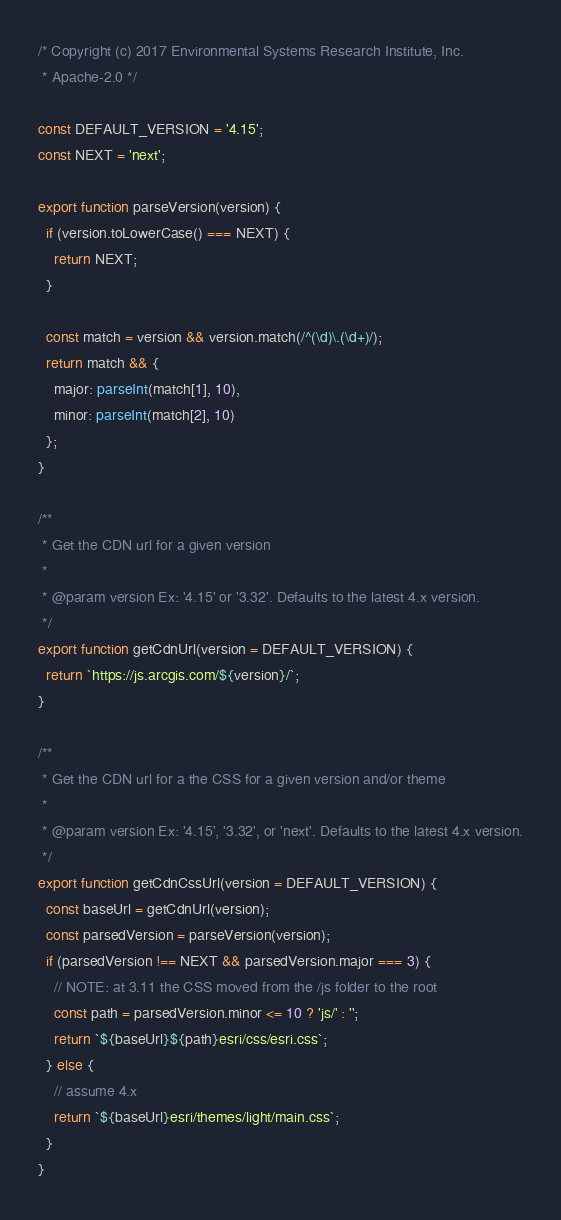<code> <loc_0><loc_0><loc_500><loc_500><_TypeScript_>/* Copyright (c) 2017 Environmental Systems Research Institute, Inc.
 * Apache-2.0 */

const DEFAULT_VERSION = '4.15';
const NEXT = 'next';

export function parseVersion(version) {
  if (version.toLowerCase() === NEXT) {
    return NEXT;
  }

  const match = version && version.match(/^(\d)\.(\d+)/);
  return match && {
    major: parseInt(match[1], 10),
    minor: parseInt(match[2], 10)
  };
}

/**
 * Get the CDN url for a given version
 *
 * @param version Ex: '4.15' or '3.32'. Defaults to the latest 4.x version.
 */
export function getCdnUrl(version = DEFAULT_VERSION) {
  return `https://js.arcgis.com/${version}/`;
}

/**
 * Get the CDN url for a the CSS for a given version and/or theme
 *
 * @param version Ex: '4.15', '3.32', or 'next'. Defaults to the latest 4.x version.
 */
export function getCdnCssUrl(version = DEFAULT_VERSION) {
  const baseUrl = getCdnUrl(version);
  const parsedVersion = parseVersion(version);
  if (parsedVersion !== NEXT && parsedVersion.major === 3) {
    // NOTE: at 3.11 the CSS moved from the /js folder to the root
    const path = parsedVersion.minor <= 10 ? 'js/' : '';
    return `${baseUrl}${path}esri/css/esri.css`;
  } else {
    // assume 4.x
    return `${baseUrl}esri/themes/light/main.css`;
  }
}
</code> 